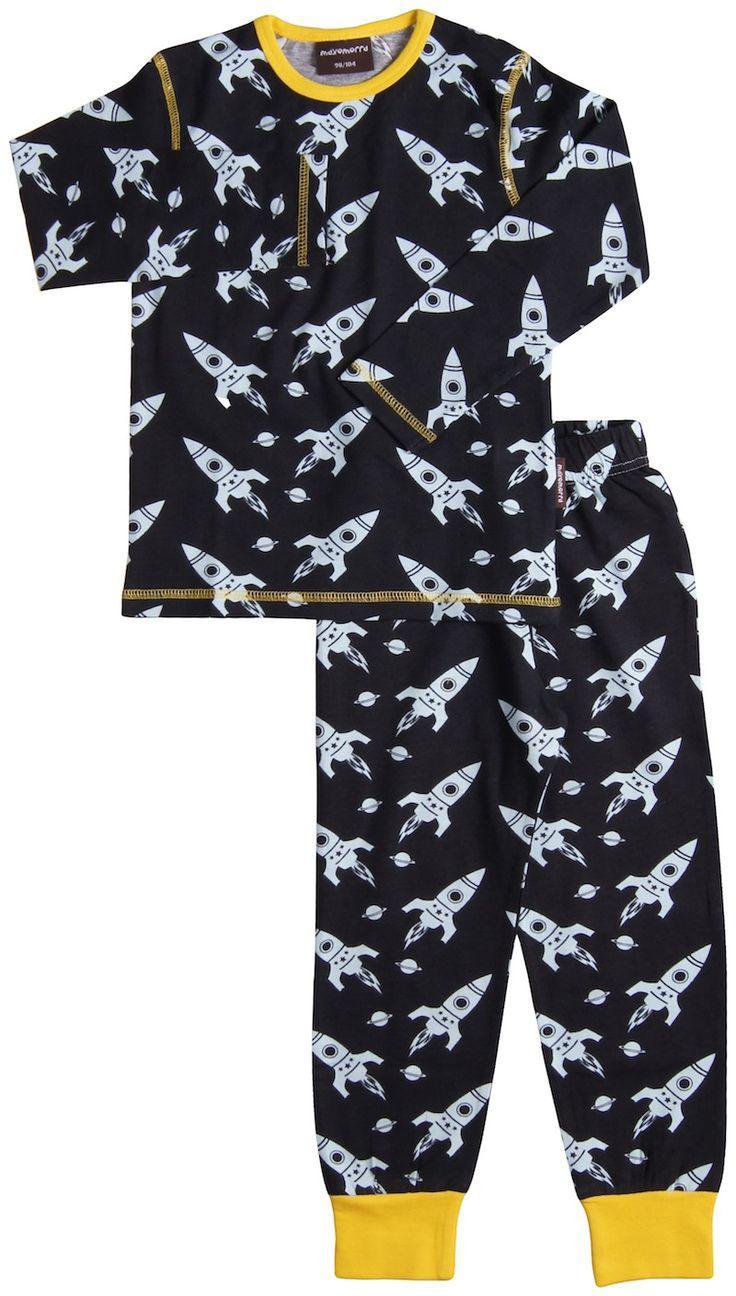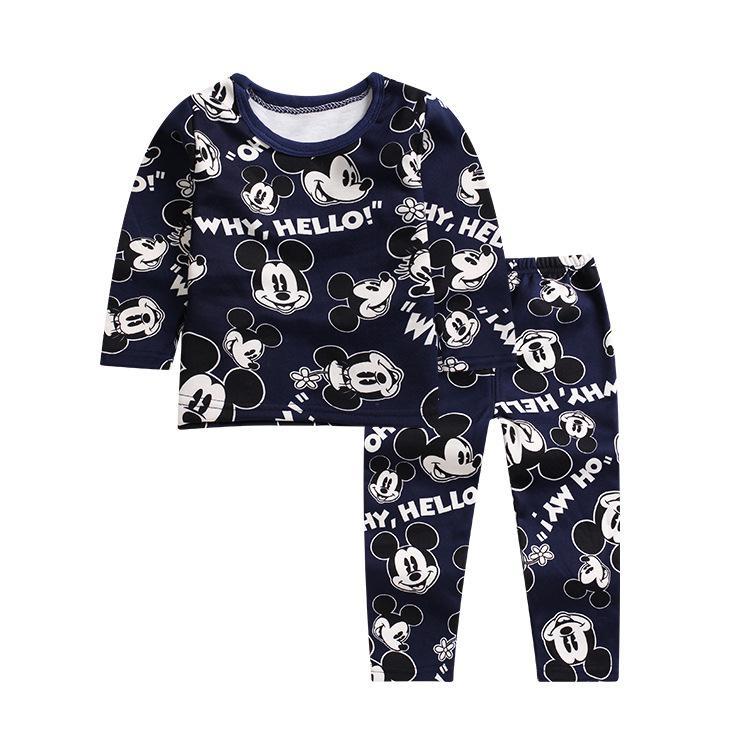The first image is the image on the left, the second image is the image on the right. Assess this claim about the two images: "At least one of the outfits has a brightly colored collar and brightly colored cuffs around the sleeves or ankles.". Correct or not? Answer yes or no. Yes. 